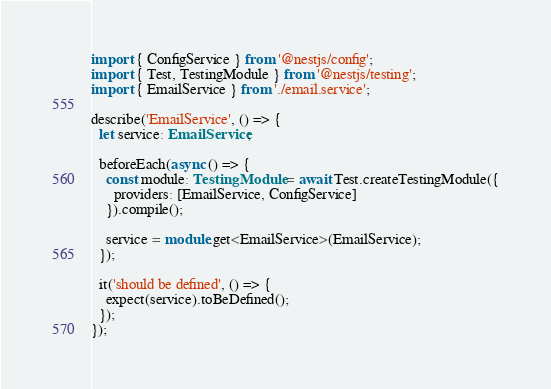<code> <loc_0><loc_0><loc_500><loc_500><_TypeScript_>import { ConfigService } from '@nestjs/config';
import { Test, TestingModule } from '@nestjs/testing';
import { EmailService } from './email.service';

describe('EmailService', () => {
  let service: EmailService;

  beforeEach(async () => {
    const module: TestingModule = await Test.createTestingModule({
      providers: [EmailService, ConfigService]
    }).compile();

    service = module.get<EmailService>(EmailService);
  });

  it('should be defined', () => {
    expect(service).toBeDefined();
  });
});
</code> 